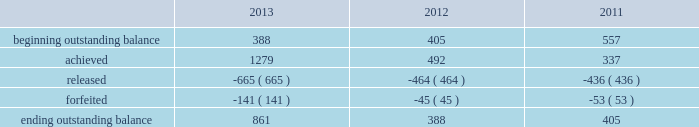Adobe systems incorporated notes to consolidated financial statements ( continued ) in the first quarter of fiscal 2013 , the executive compensation committee certified the actual performance achievement of participants in the 2012 performance share program ( the 201c2012 program 201d ) .
Based upon the achievement of specific and/or market- based performance goals outlined in the 2012 program , participants had the ability to receive up to 150% ( 150 % ) of the target number of shares originally granted .
Actual performance resulted in participants achieving 116% ( 116 % ) of target or approximately 1.3 million shares for the 2012 program .
One third of the shares under the 2012 program vested in the first quarter of fiscal 2013 and the remaining two thirds vest evenly on the following two anniversaries of the grant , contingent upon the recipient's continued service to adobe .
In the first quarter of fiscal 2012 , the executive compensation committee certified the actual performance achievement of participants in the 2011 performance share program ( the 201c2011 program 201d ) .
Based upon the achievement of goals outlined in the 2011 program , participants had the ability to receive up to 150% ( 150 % ) of the target number of shares originally granted .
Actual performance resulted in participants achieving 130% ( 130 % ) of target or approximately 0.5 million shares for the 2011 program .
One third of the shares under the 2011 program vested in the first quarter of fiscal 2012 and the remaining two thirds vest evenly on the following two annual anniversary dates of the grant , contingent upon the recipient's continued service to adobe .
In the first quarter of fiscal 2011 , the executive compensation committee certified the actual performance achievement of participants in the 2010 performance share program ( the 201c2010 program 201d ) .
Based upon the achievement of goals outlined in the 2010 program , participants had the ability to receive up to 150% ( 150 % ) of the target number of shares originally granted .
Actual performance resulted in participants achieving 135% ( 135 % ) of target or approximately 0.3 million shares for the 2010 program .
One third of the shares under the 2011 program vested in the first quarter of fiscal 2012 and the remaining two thirds vest evenly on the following two annual anniversary dates of the grant , contingent upon the recipient's continued service to adobe .
The table sets forth the summary of performance share activity under our 2010 , 2011 and 2012 programs , based upon share awards actually achieved , for the fiscal years ended november 29 , 2013 , november 30 , 2012 and december 2 , 2011 ( in thousands ) : .
The total fair value of performance awards vested during fiscal 2013 , 2012 and 2011 was $ 25.4 million , $ 14.4 million and $ 14.8 million , respectively. .
For the performance share program , for the years 2013 , 2012 , and 2011 , what was the maximum shares in the beginning outstanding balance in thousands? 
Computations: table_max(beginning outstanding balance, none)
Answer: 557.0. 